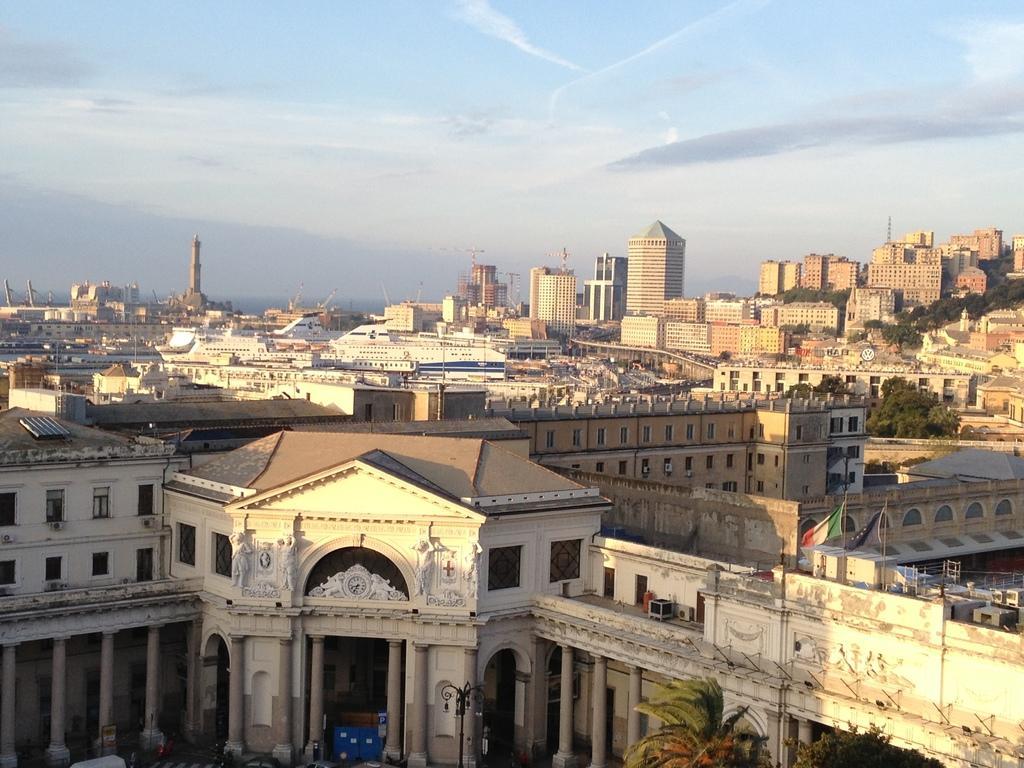Can you describe this image briefly? This image is taken outdoors. At the top of the image there is the sky with clouds. In the middle of the image there are many buildings, houses and towers. There is a building with walls, windows, doors, a roof and pillars. There are few trees. There is a pole with a street light. There are a few ships and there is a bridge. 